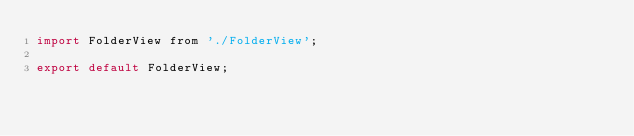<code> <loc_0><loc_0><loc_500><loc_500><_JavaScript_>import FolderView from './FolderView';

export default FolderView;
</code> 